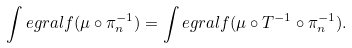Convert formula to latex. <formula><loc_0><loc_0><loc_500><loc_500>\int e g r a l { f } { ( \mu \circ \pi _ { n } ^ { - 1 } ) } = \int e g r a l { f } { ( \mu \circ T ^ { - 1 } \circ \pi _ { n } ^ { - 1 } ) } .</formula> 